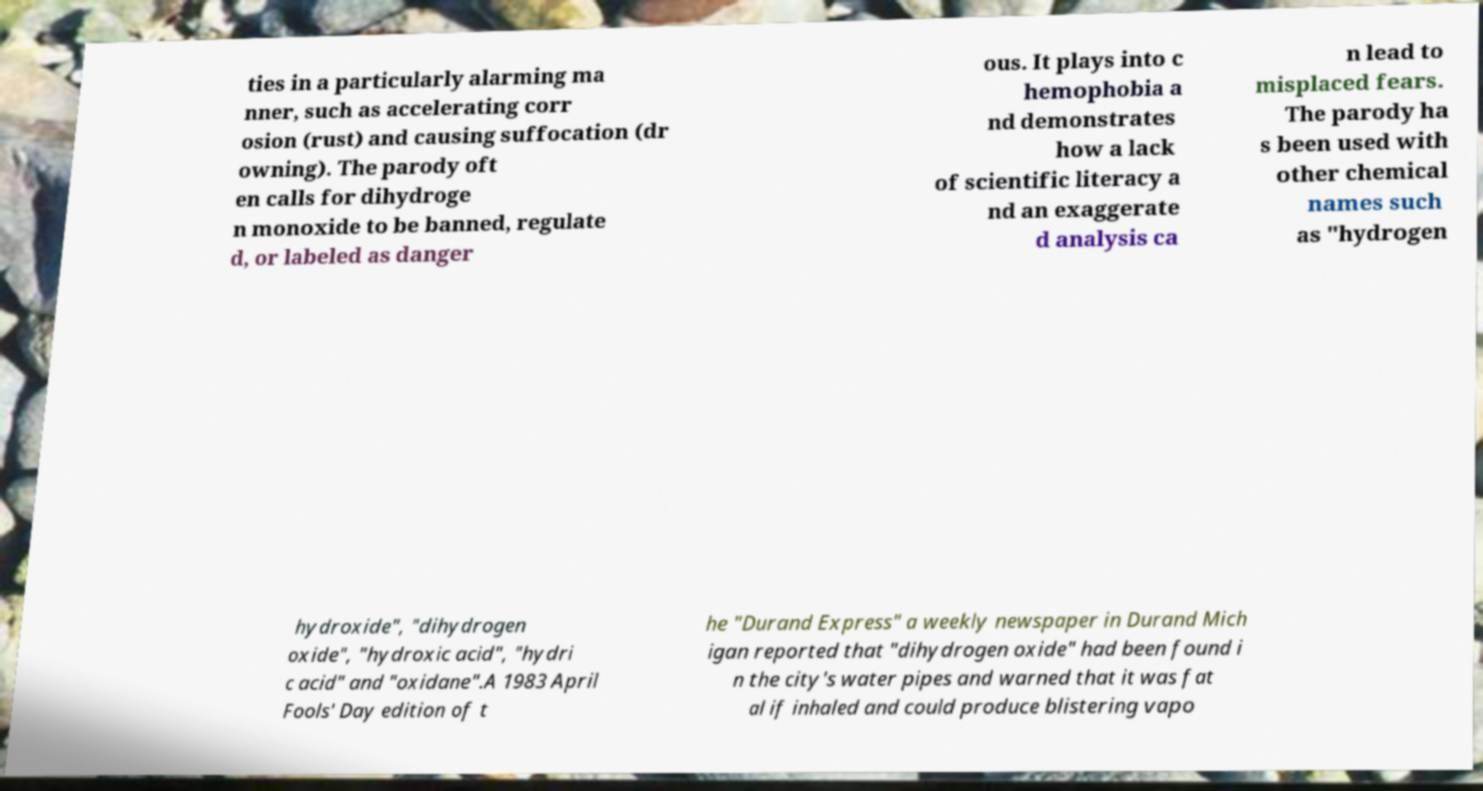For documentation purposes, I need the text within this image transcribed. Could you provide that? ties in a particularly alarming ma nner, such as accelerating corr osion (rust) and causing suffocation (dr owning). The parody oft en calls for dihydroge n monoxide to be banned, regulate d, or labeled as danger ous. It plays into c hemophobia a nd demonstrates how a lack of scientific literacy a nd an exaggerate d analysis ca n lead to misplaced fears. The parody ha s been used with other chemical names such as "hydrogen hydroxide", "dihydrogen oxide", "hydroxic acid", "hydri c acid" and "oxidane".A 1983 April Fools' Day edition of t he "Durand Express" a weekly newspaper in Durand Mich igan reported that "dihydrogen oxide" had been found i n the city's water pipes and warned that it was fat al if inhaled and could produce blistering vapo 